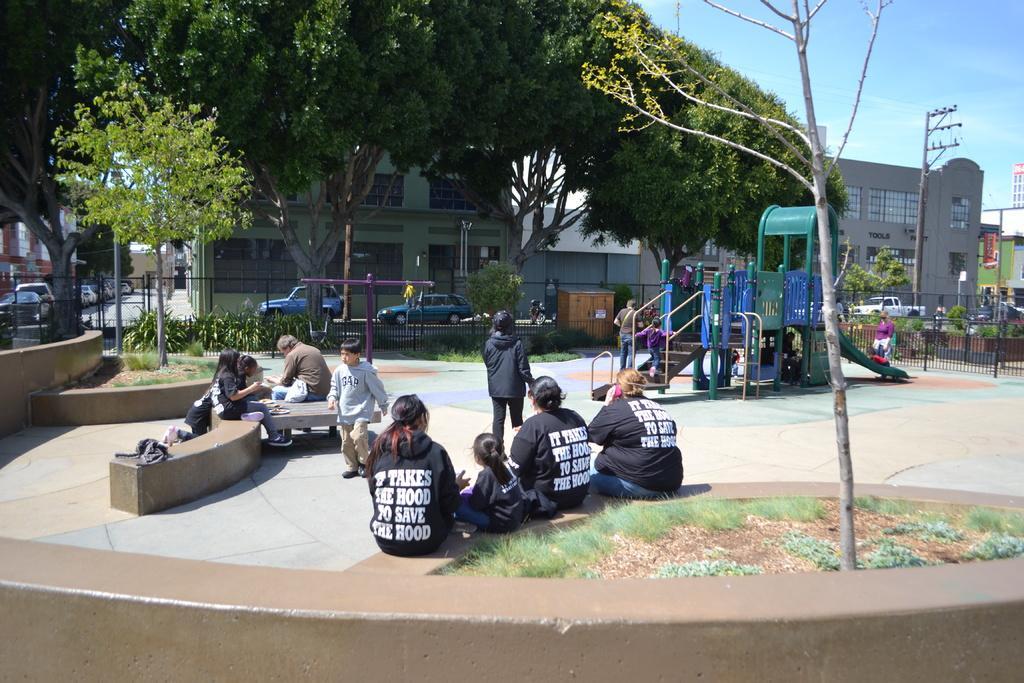Can you describe this image briefly? In this image we can see a few people, among them, some people are sitting and some people are standing, there are some trees, buildings, plants, vehicles, poles, lights, fence and a slide. In the background, we can see the sky. 